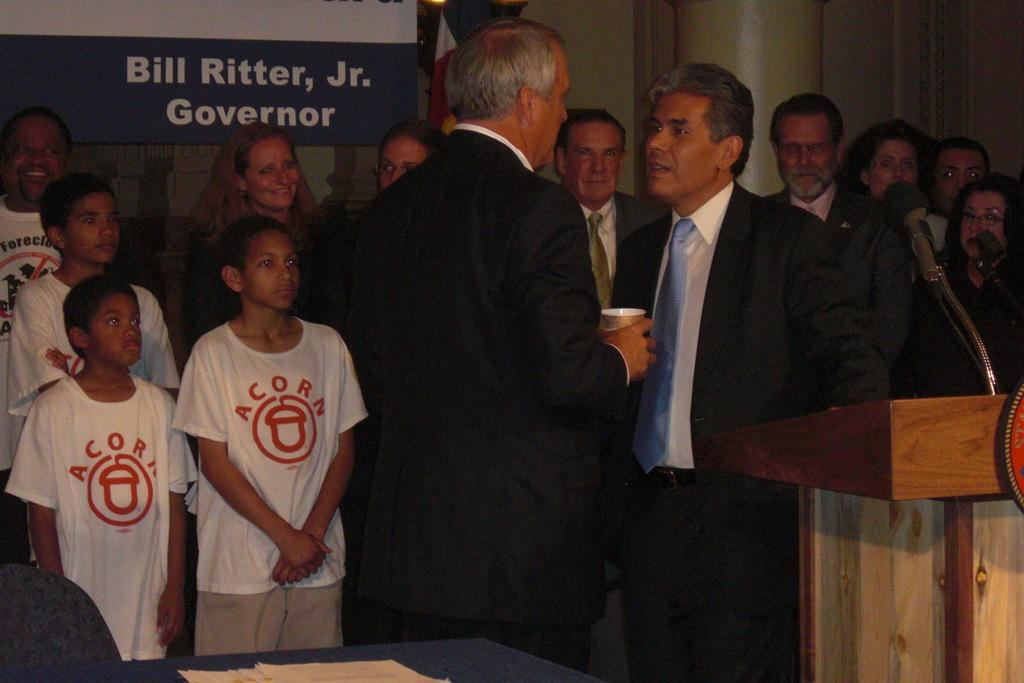<image>
Write a terse but informative summary of the picture. a couple people talking and some kids with acorn shirts on 